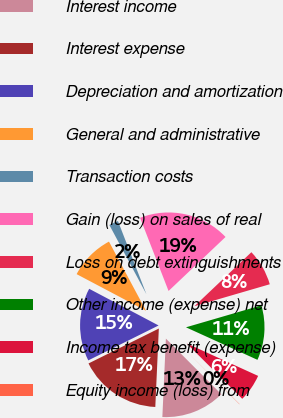Convert chart. <chart><loc_0><loc_0><loc_500><loc_500><pie_chart><fcel>Interest income<fcel>Interest expense<fcel>Depreciation and amortization<fcel>General and administrative<fcel>Transaction costs<fcel>Gain (loss) on sales of real<fcel>Loss on debt extinguishments<fcel>Other income (expense) net<fcel>Income tax benefit (expense)<fcel>Equity income (loss) from<nl><fcel>13.19%<fcel>16.95%<fcel>15.07%<fcel>9.44%<fcel>1.92%<fcel>18.83%<fcel>7.56%<fcel>11.31%<fcel>5.68%<fcel>0.05%<nl></chart> 